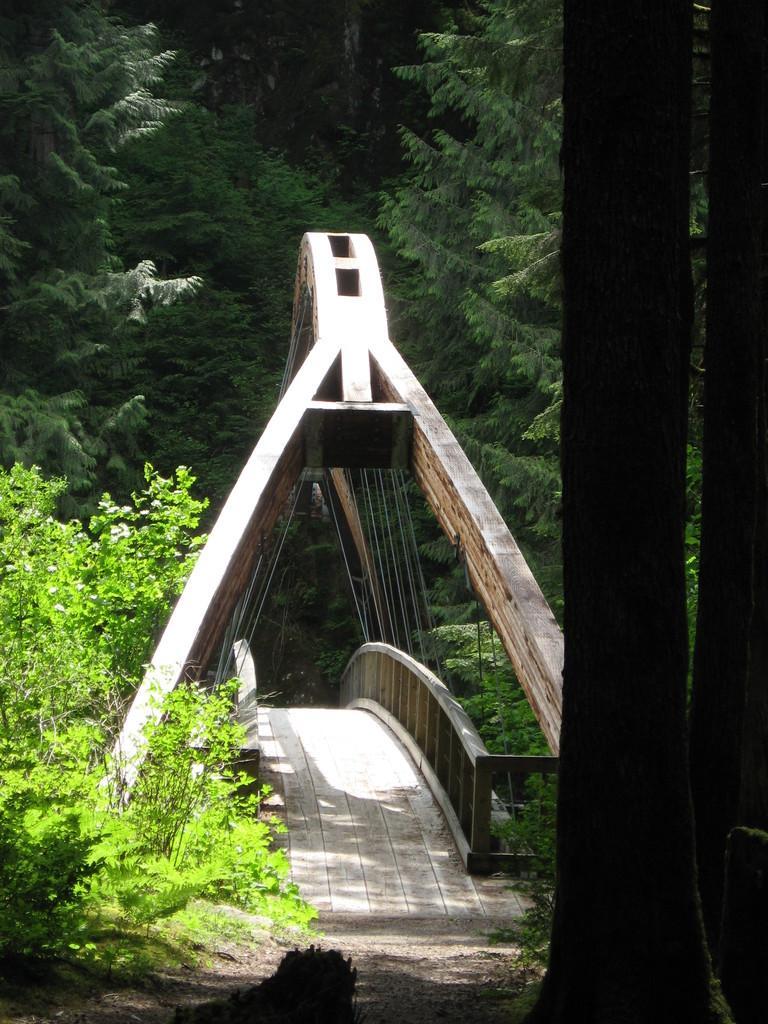Can you describe this image briefly? In this image, we can see some trees and plants. There are stems on the right side of the image. There is a bridge in the middle of the image. 